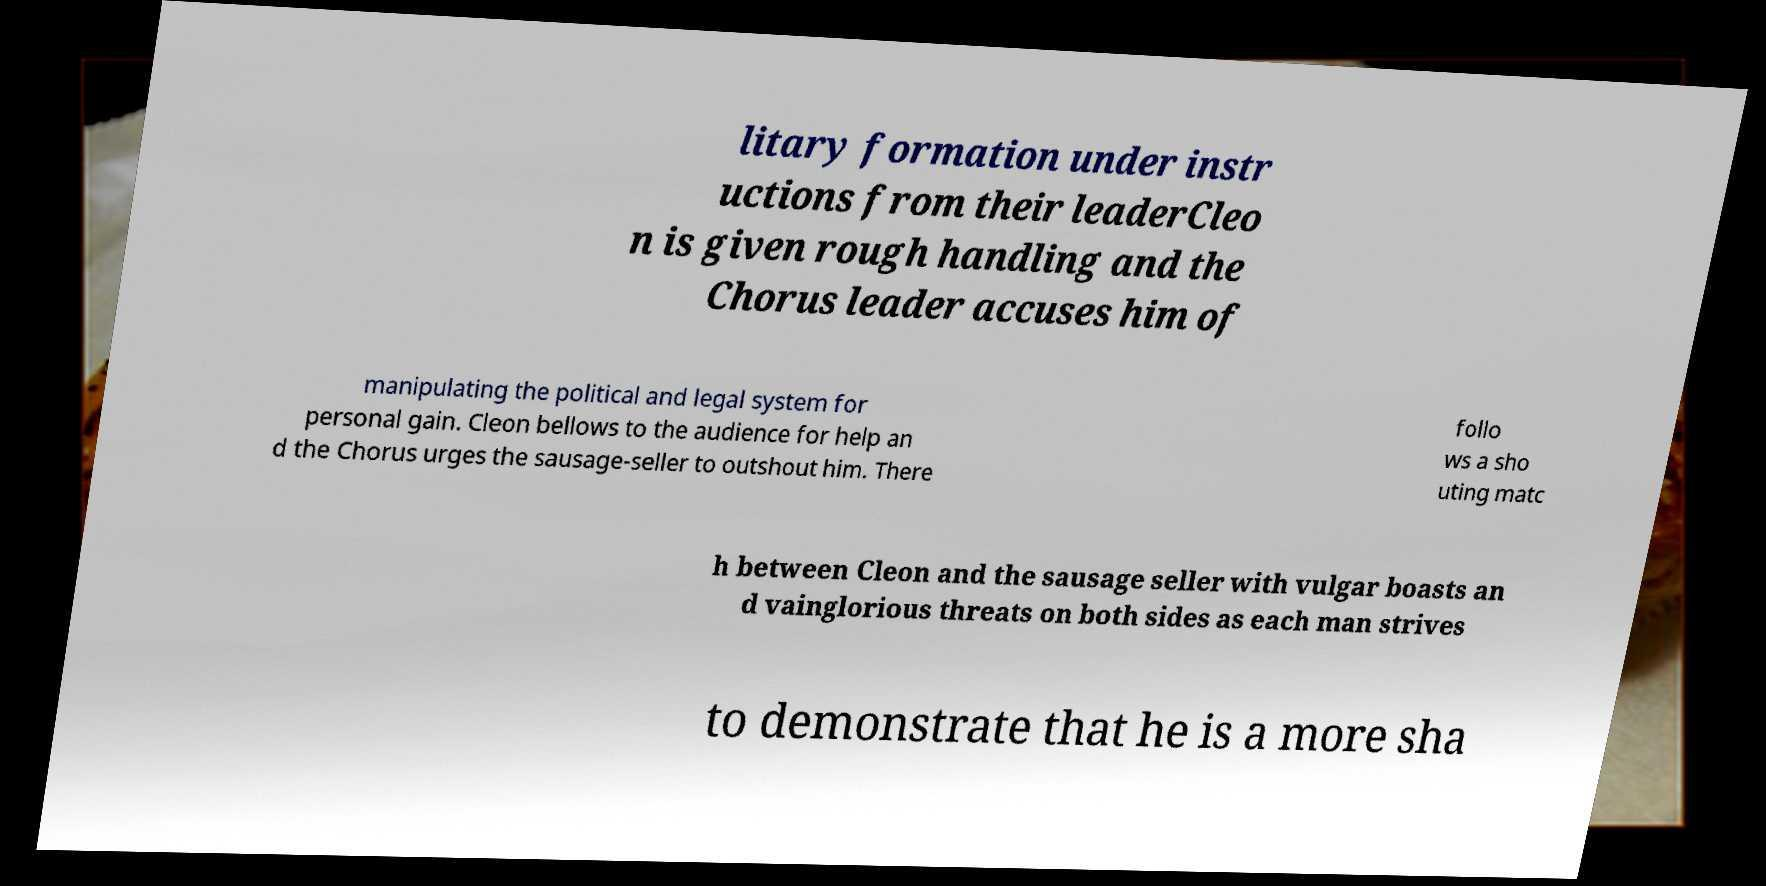There's text embedded in this image that I need extracted. Can you transcribe it verbatim? litary formation under instr uctions from their leaderCleo n is given rough handling and the Chorus leader accuses him of manipulating the political and legal system for personal gain. Cleon bellows to the audience for help an d the Chorus urges the sausage-seller to outshout him. There follo ws a sho uting matc h between Cleon and the sausage seller with vulgar boasts an d vainglorious threats on both sides as each man strives to demonstrate that he is a more sha 